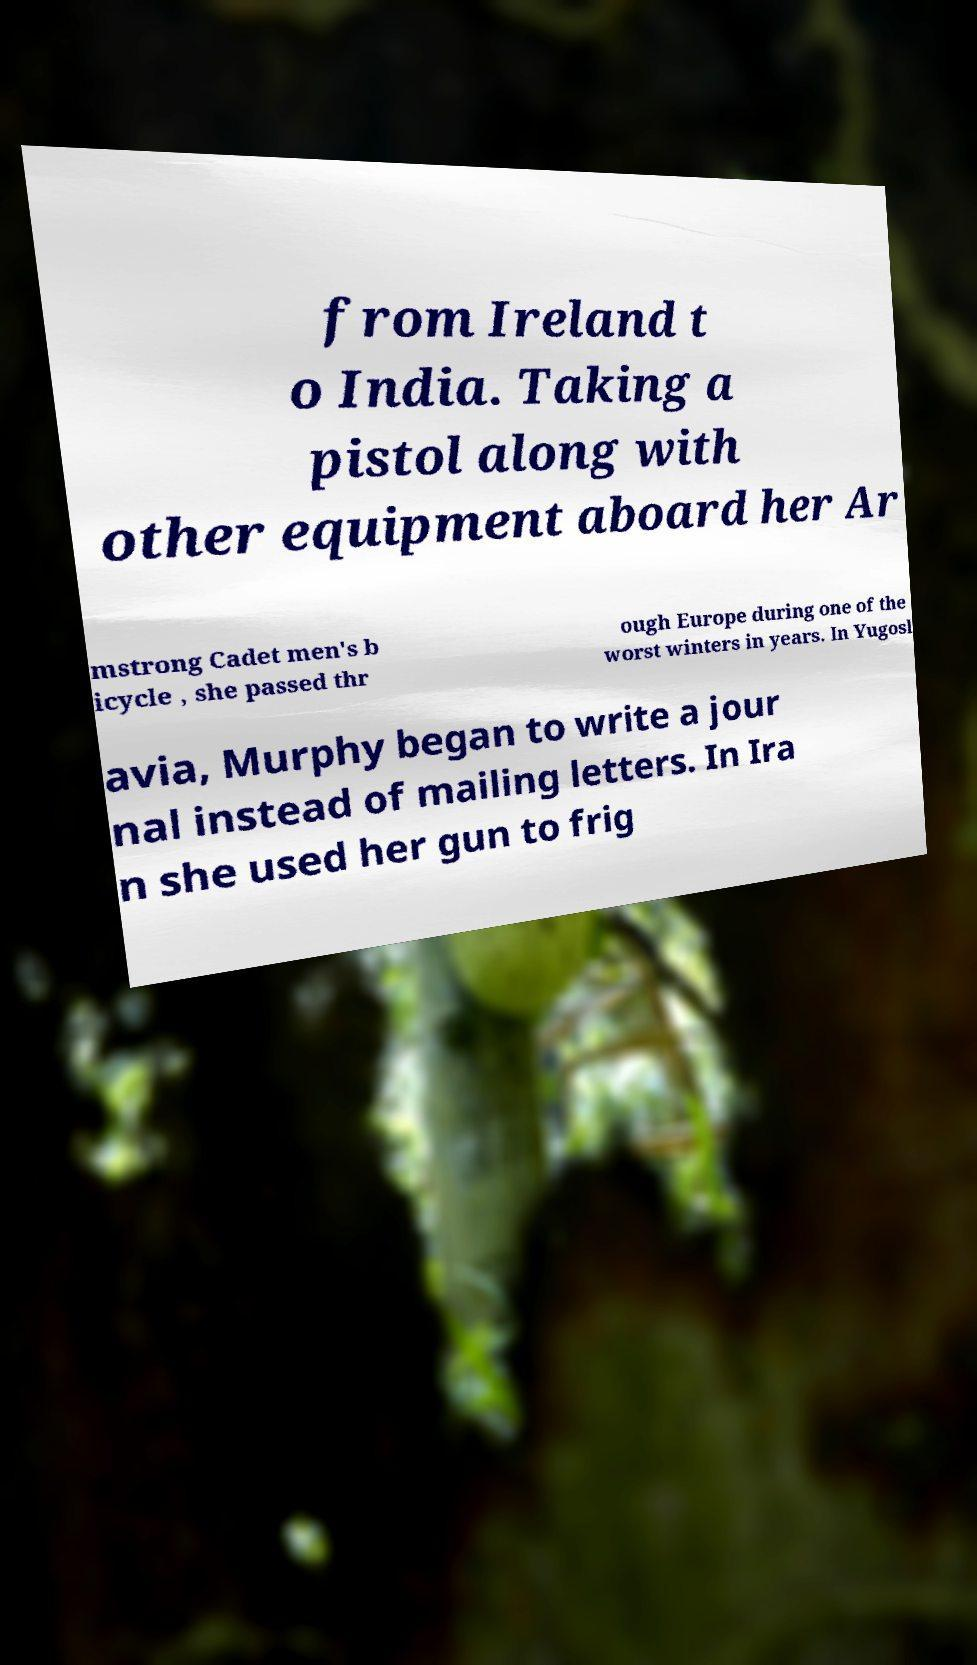Could you extract and type out the text from this image? from Ireland t o India. Taking a pistol along with other equipment aboard her Ar mstrong Cadet men's b icycle , she passed thr ough Europe during one of the worst winters in years. In Yugosl avia, Murphy began to write a jour nal instead of mailing letters. In Ira n she used her gun to frig 